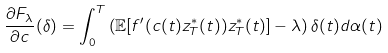Convert formula to latex. <formula><loc_0><loc_0><loc_500><loc_500>\frac { \partial F _ { \lambda } } { \partial c } ( \delta ) = \int _ { 0 } ^ { T } \left ( \mathbb { E } [ f ^ { \prime } ( c ( t ) z ^ { * } _ { T } ( t ) ) z ^ { * } _ { T } ( t ) ] - \lambda \right ) \delta ( t ) d \alpha ( t )</formula> 